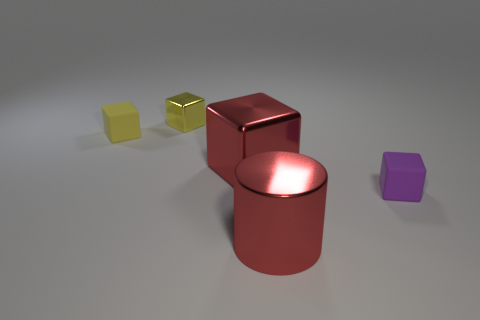What material is the big red object that is the same shape as the yellow rubber object?
Offer a terse response. Metal. Are there fewer large red blocks that are behind the red cube than tiny yellow objects that are to the left of the purple thing?
Your response must be concise. Yes. There is a thing that is the same color as the big cylinder; what size is it?
Your response must be concise. Large. How many small yellow things are in front of the small rubber object that is on the right side of the cube on the left side of the yellow metal block?
Keep it short and to the point. 0. Is the tiny metal thing the same color as the big metal block?
Keep it short and to the point. No. Are there any small objects that have the same color as the metal cylinder?
Provide a short and direct response. No. What color is the metal cylinder that is the same size as the red metal cube?
Offer a terse response. Red. Is there a brown rubber object of the same shape as the small yellow matte thing?
Keep it short and to the point. No. What is the shape of the big thing that is the same color as the large cube?
Your answer should be compact. Cylinder. Are there any yellow blocks that are in front of the yellow block that is to the left of the yellow shiny cube behind the small yellow matte cube?
Offer a terse response. No. 